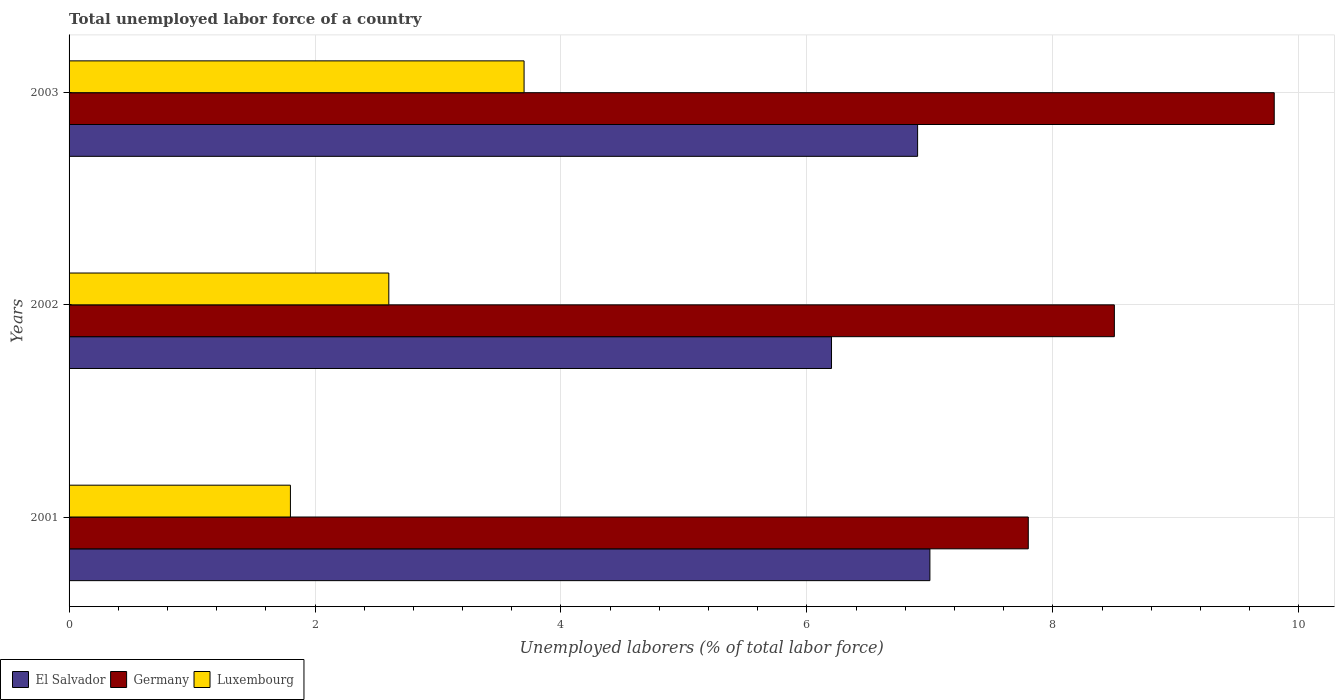How many bars are there on the 1st tick from the top?
Your response must be concise. 3. How many bars are there on the 3rd tick from the bottom?
Your answer should be compact. 3. What is the label of the 2nd group of bars from the top?
Give a very brief answer. 2002. What is the total unemployed labor force in Luxembourg in 2001?
Offer a terse response. 1.8. Across all years, what is the maximum total unemployed labor force in Luxembourg?
Offer a terse response. 3.7. Across all years, what is the minimum total unemployed labor force in Germany?
Your answer should be compact. 7.8. What is the total total unemployed labor force in El Salvador in the graph?
Your response must be concise. 20.1. What is the difference between the total unemployed labor force in Luxembourg in 2001 and that in 2002?
Provide a succinct answer. -0.8. What is the difference between the total unemployed labor force in El Salvador in 2001 and the total unemployed labor force in Germany in 2003?
Offer a very short reply. -2.8. What is the average total unemployed labor force in El Salvador per year?
Offer a terse response. 6.7. In the year 2003, what is the difference between the total unemployed labor force in Germany and total unemployed labor force in El Salvador?
Give a very brief answer. 2.9. In how many years, is the total unemployed labor force in Germany greater than 1.2000000000000002 %?
Your answer should be compact. 3. What is the ratio of the total unemployed labor force in Germany in 2002 to that in 2003?
Make the answer very short. 0.87. Is the total unemployed labor force in El Salvador in 2002 less than that in 2003?
Provide a succinct answer. Yes. What is the difference between the highest and the second highest total unemployed labor force in Germany?
Your answer should be compact. 1.3. What is the difference between the highest and the lowest total unemployed labor force in Germany?
Your response must be concise. 2. What does the 1st bar from the top in 2002 represents?
Keep it short and to the point. Luxembourg. What does the 1st bar from the bottom in 2003 represents?
Your answer should be very brief. El Salvador. How many years are there in the graph?
Make the answer very short. 3. Does the graph contain grids?
Provide a short and direct response. Yes. How are the legend labels stacked?
Offer a very short reply. Horizontal. What is the title of the graph?
Your response must be concise. Total unemployed labor force of a country. What is the label or title of the X-axis?
Offer a very short reply. Unemployed laborers (% of total labor force). What is the label or title of the Y-axis?
Provide a short and direct response. Years. What is the Unemployed laborers (% of total labor force) of Germany in 2001?
Provide a short and direct response. 7.8. What is the Unemployed laborers (% of total labor force) of Luxembourg in 2001?
Offer a terse response. 1.8. What is the Unemployed laborers (% of total labor force) in El Salvador in 2002?
Provide a short and direct response. 6.2. What is the Unemployed laborers (% of total labor force) of Luxembourg in 2002?
Your response must be concise. 2.6. What is the Unemployed laborers (% of total labor force) in El Salvador in 2003?
Your answer should be very brief. 6.9. What is the Unemployed laborers (% of total labor force) in Germany in 2003?
Your response must be concise. 9.8. What is the Unemployed laborers (% of total labor force) of Luxembourg in 2003?
Offer a very short reply. 3.7. Across all years, what is the maximum Unemployed laborers (% of total labor force) of El Salvador?
Ensure brevity in your answer.  7. Across all years, what is the maximum Unemployed laborers (% of total labor force) in Germany?
Make the answer very short. 9.8. Across all years, what is the maximum Unemployed laborers (% of total labor force) of Luxembourg?
Your response must be concise. 3.7. Across all years, what is the minimum Unemployed laborers (% of total labor force) in El Salvador?
Your answer should be very brief. 6.2. Across all years, what is the minimum Unemployed laborers (% of total labor force) in Germany?
Provide a succinct answer. 7.8. Across all years, what is the minimum Unemployed laborers (% of total labor force) in Luxembourg?
Ensure brevity in your answer.  1.8. What is the total Unemployed laborers (% of total labor force) in El Salvador in the graph?
Offer a very short reply. 20.1. What is the total Unemployed laborers (% of total labor force) in Germany in the graph?
Make the answer very short. 26.1. What is the difference between the Unemployed laborers (% of total labor force) in El Salvador in 2001 and that in 2002?
Your response must be concise. 0.8. What is the difference between the Unemployed laborers (% of total labor force) of Germany in 2001 and that in 2002?
Provide a succinct answer. -0.7. What is the difference between the Unemployed laborers (% of total labor force) of Luxembourg in 2001 and that in 2002?
Provide a short and direct response. -0.8. What is the difference between the Unemployed laborers (% of total labor force) in Germany in 2001 and that in 2003?
Your answer should be compact. -2. What is the difference between the Unemployed laborers (% of total labor force) of Luxembourg in 2001 and that in 2003?
Keep it short and to the point. -1.9. What is the difference between the Unemployed laborers (% of total labor force) in El Salvador in 2002 and that in 2003?
Give a very brief answer. -0.7. What is the difference between the Unemployed laborers (% of total labor force) of El Salvador in 2001 and the Unemployed laborers (% of total labor force) of Germany in 2002?
Your response must be concise. -1.5. What is the difference between the Unemployed laborers (% of total labor force) in Germany in 2001 and the Unemployed laborers (% of total labor force) in Luxembourg in 2002?
Give a very brief answer. 5.2. What is the difference between the Unemployed laborers (% of total labor force) in El Salvador in 2001 and the Unemployed laborers (% of total labor force) in Luxembourg in 2003?
Your answer should be compact. 3.3. What is the difference between the Unemployed laborers (% of total labor force) in Germany in 2001 and the Unemployed laborers (% of total labor force) in Luxembourg in 2003?
Provide a short and direct response. 4.1. What is the difference between the Unemployed laborers (% of total labor force) in El Salvador in 2002 and the Unemployed laborers (% of total labor force) in Germany in 2003?
Ensure brevity in your answer.  -3.6. What is the difference between the Unemployed laborers (% of total labor force) in Germany in 2002 and the Unemployed laborers (% of total labor force) in Luxembourg in 2003?
Your answer should be very brief. 4.8. What is the average Unemployed laborers (% of total labor force) of Luxembourg per year?
Provide a short and direct response. 2.7. In the year 2001, what is the difference between the Unemployed laborers (% of total labor force) of El Salvador and Unemployed laborers (% of total labor force) of Germany?
Your answer should be compact. -0.8. In the year 2001, what is the difference between the Unemployed laborers (% of total labor force) of Germany and Unemployed laborers (% of total labor force) of Luxembourg?
Offer a terse response. 6. In the year 2002, what is the difference between the Unemployed laborers (% of total labor force) of El Salvador and Unemployed laborers (% of total labor force) of Luxembourg?
Ensure brevity in your answer.  3.6. In the year 2002, what is the difference between the Unemployed laborers (% of total labor force) in Germany and Unemployed laborers (% of total labor force) in Luxembourg?
Provide a short and direct response. 5.9. In the year 2003, what is the difference between the Unemployed laborers (% of total labor force) in El Salvador and Unemployed laborers (% of total labor force) in Germany?
Your response must be concise. -2.9. In the year 2003, what is the difference between the Unemployed laborers (% of total labor force) of El Salvador and Unemployed laborers (% of total labor force) of Luxembourg?
Keep it short and to the point. 3.2. In the year 2003, what is the difference between the Unemployed laborers (% of total labor force) of Germany and Unemployed laborers (% of total labor force) of Luxembourg?
Your answer should be very brief. 6.1. What is the ratio of the Unemployed laborers (% of total labor force) in El Salvador in 2001 to that in 2002?
Offer a very short reply. 1.13. What is the ratio of the Unemployed laborers (% of total labor force) of Germany in 2001 to that in 2002?
Give a very brief answer. 0.92. What is the ratio of the Unemployed laborers (% of total labor force) in Luxembourg in 2001 to that in 2002?
Keep it short and to the point. 0.69. What is the ratio of the Unemployed laborers (% of total labor force) of El Salvador in 2001 to that in 2003?
Provide a short and direct response. 1.01. What is the ratio of the Unemployed laborers (% of total labor force) of Germany in 2001 to that in 2003?
Provide a short and direct response. 0.8. What is the ratio of the Unemployed laborers (% of total labor force) in Luxembourg in 2001 to that in 2003?
Your response must be concise. 0.49. What is the ratio of the Unemployed laborers (% of total labor force) in El Salvador in 2002 to that in 2003?
Your response must be concise. 0.9. What is the ratio of the Unemployed laborers (% of total labor force) of Germany in 2002 to that in 2003?
Give a very brief answer. 0.87. What is the ratio of the Unemployed laborers (% of total labor force) in Luxembourg in 2002 to that in 2003?
Ensure brevity in your answer.  0.7. What is the difference between the highest and the second highest Unemployed laborers (% of total labor force) of Luxembourg?
Provide a succinct answer. 1.1. What is the difference between the highest and the lowest Unemployed laborers (% of total labor force) of Germany?
Keep it short and to the point. 2. What is the difference between the highest and the lowest Unemployed laborers (% of total labor force) of Luxembourg?
Provide a short and direct response. 1.9. 